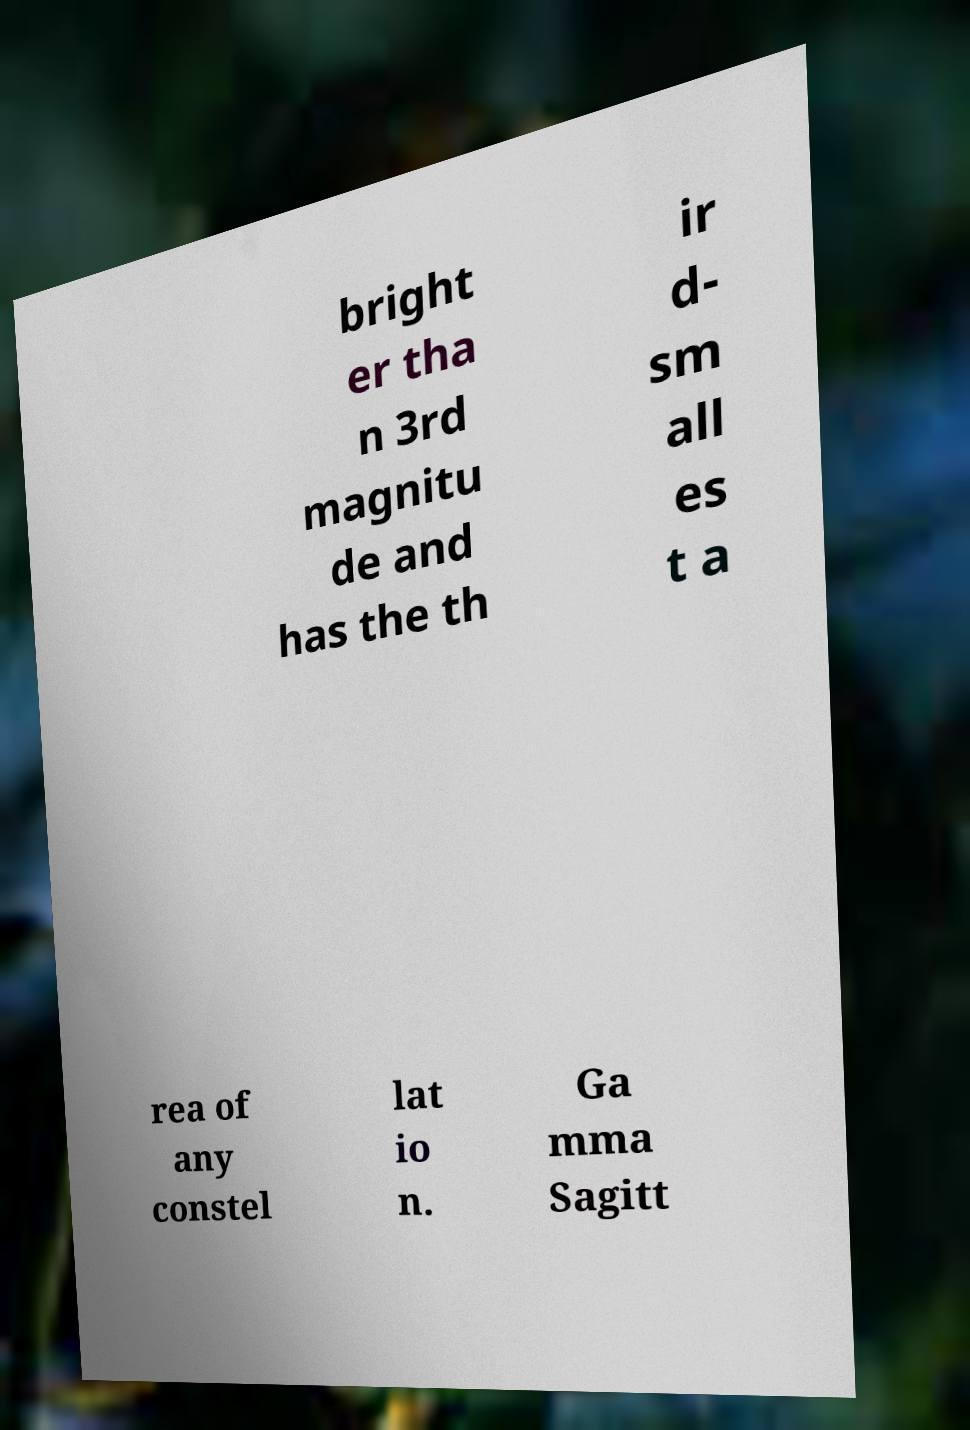What messages or text are displayed in this image? I need them in a readable, typed format. bright er tha n 3rd magnitu de and has the th ir d- sm all es t a rea of any constel lat io n. Ga mma Sagitt 